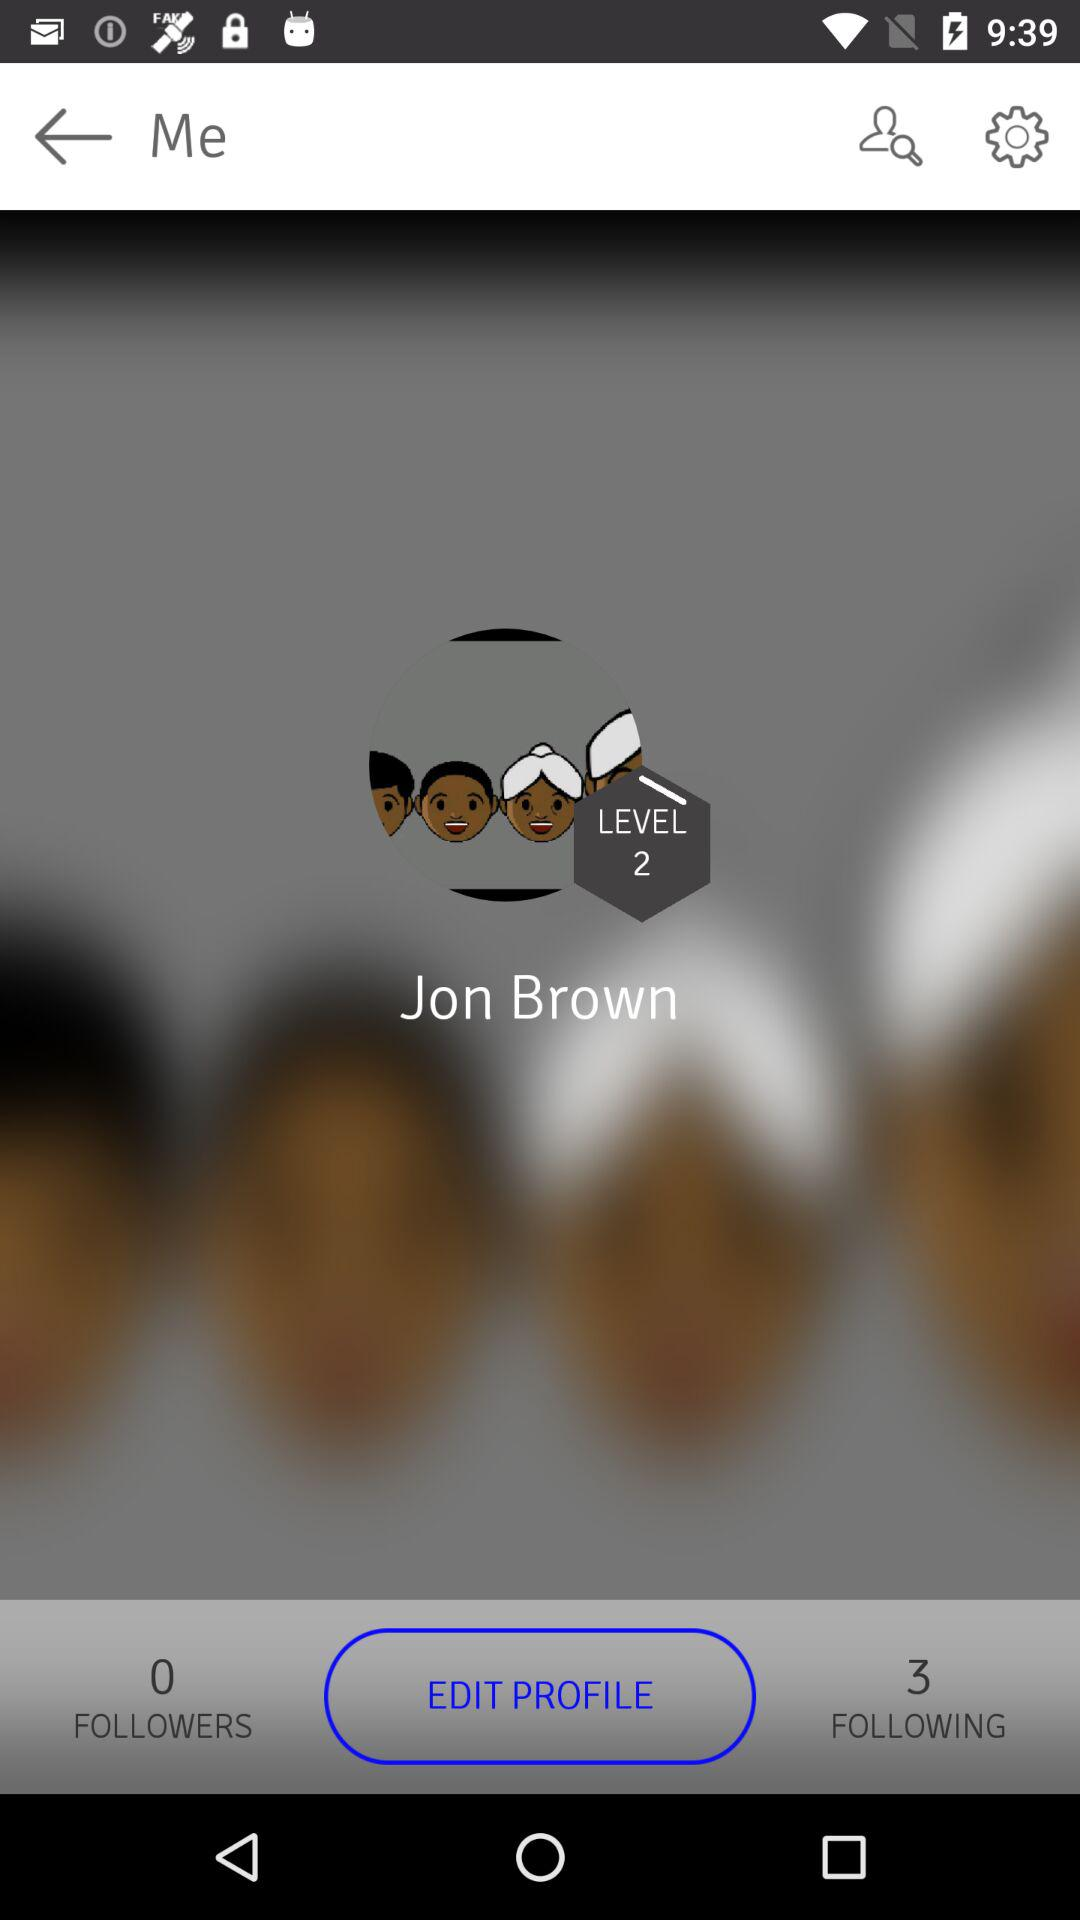How many more followers does Jon Brown have than following?
Answer the question using a single word or phrase. 3 